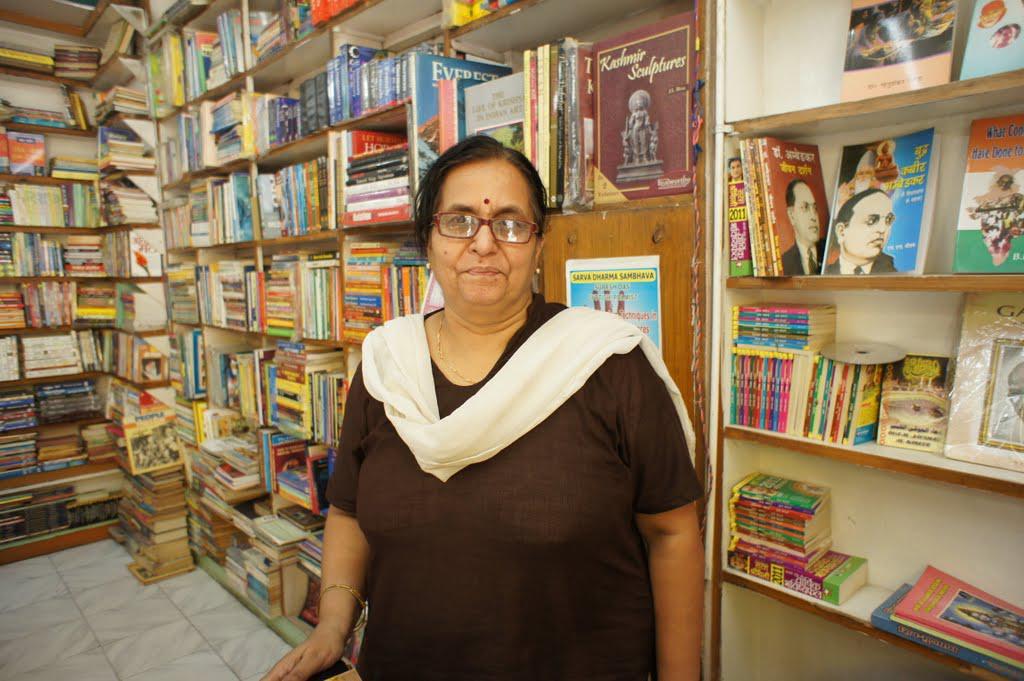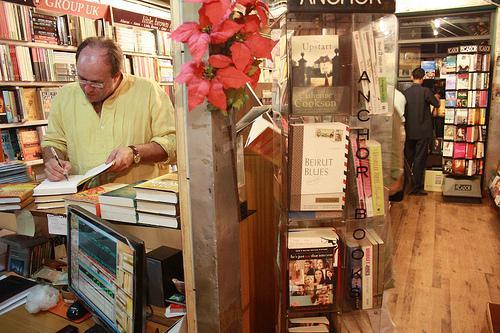The first image is the image on the left, the second image is the image on the right. Considering the images on both sides, is "A person poses for their picture in the left image." valid? Answer yes or no. Yes. 